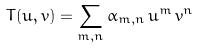Convert formula to latex. <formula><loc_0><loc_0><loc_500><loc_500>T ( u , v ) = \sum _ { m , n } \alpha _ { m , n } \, u ^ { m } \, v ^ { n }</formula> 